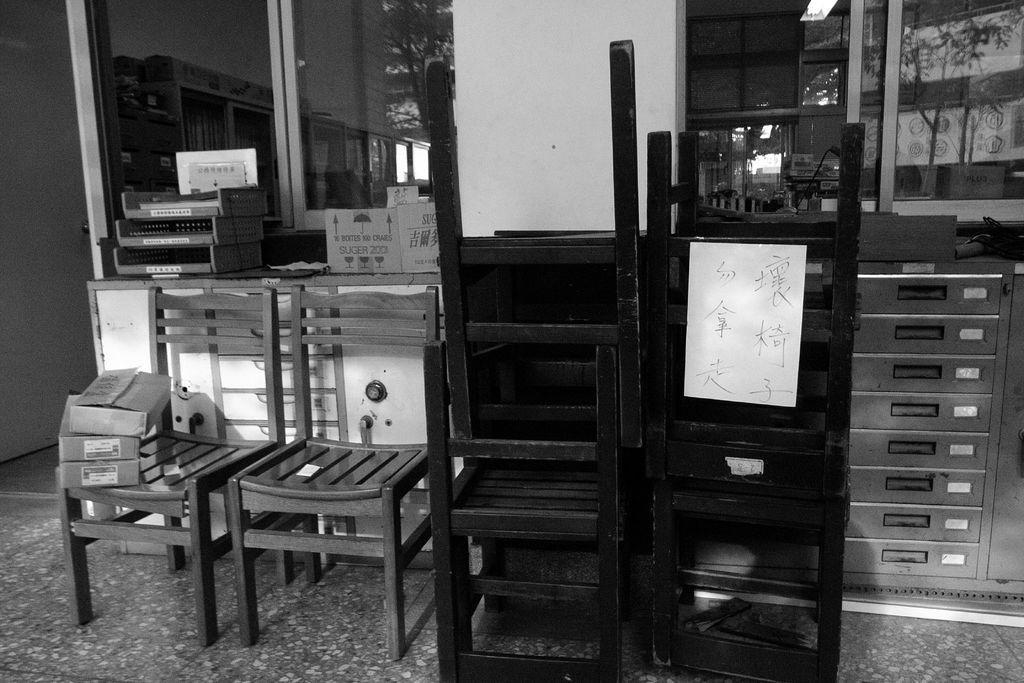Can you describe this image briefly? This picture is clicked inside. In the foreground we can see the wooden chairs and there are some boxes and some other items placed on the top of the cabinet. In the background we can see the wall and the windows and many other objects. 